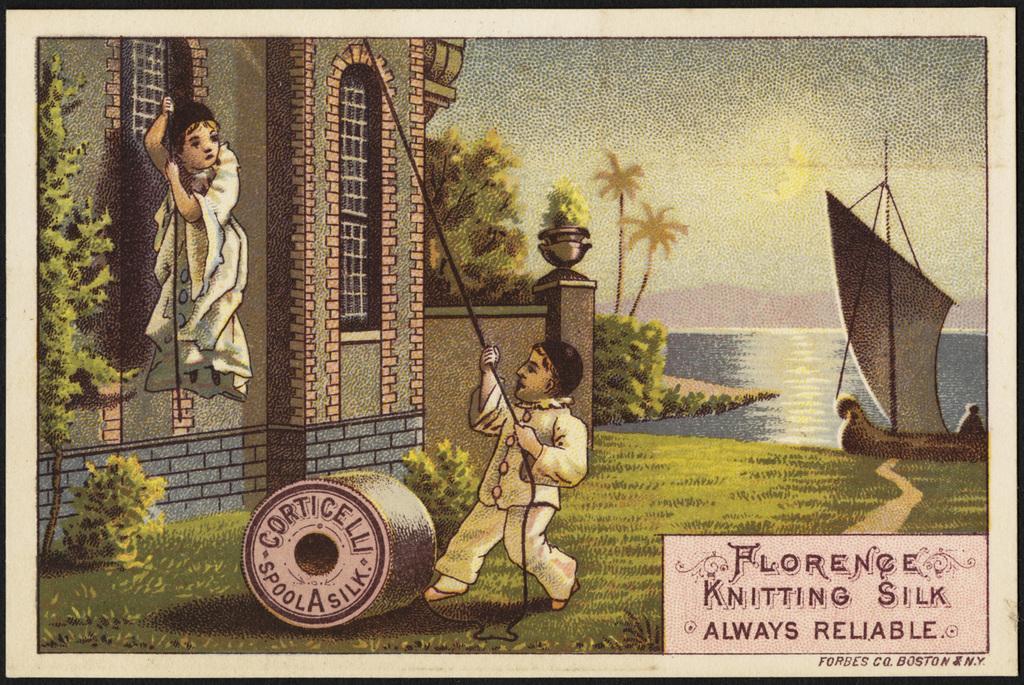How would you summarize this image in a sentence or two? In this picture there are two persons. One is holding the rope and the other one is pulling the rope. In the left side there are some plants. We can observe a house here. There is some grass on the ground. In the right side there is a boat. In the background there is a river, some trees, hills and a sky. 